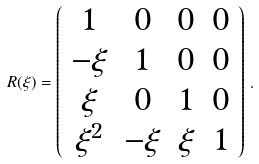<formula> <loc_0><loc_0><loc_500><loc_500>R ( \xi ) = \left ( \begin{array} { c c c c c c c c c } 1 & 0 & 0 & 0 \\ - \xi & 1 & 0 & 0 \\ \xi & 0 & 1 & 0 \\ \xi ^ { 2 } & - \xi & \xi & 1 \\ \end{array} \right ) \, .</formula> 